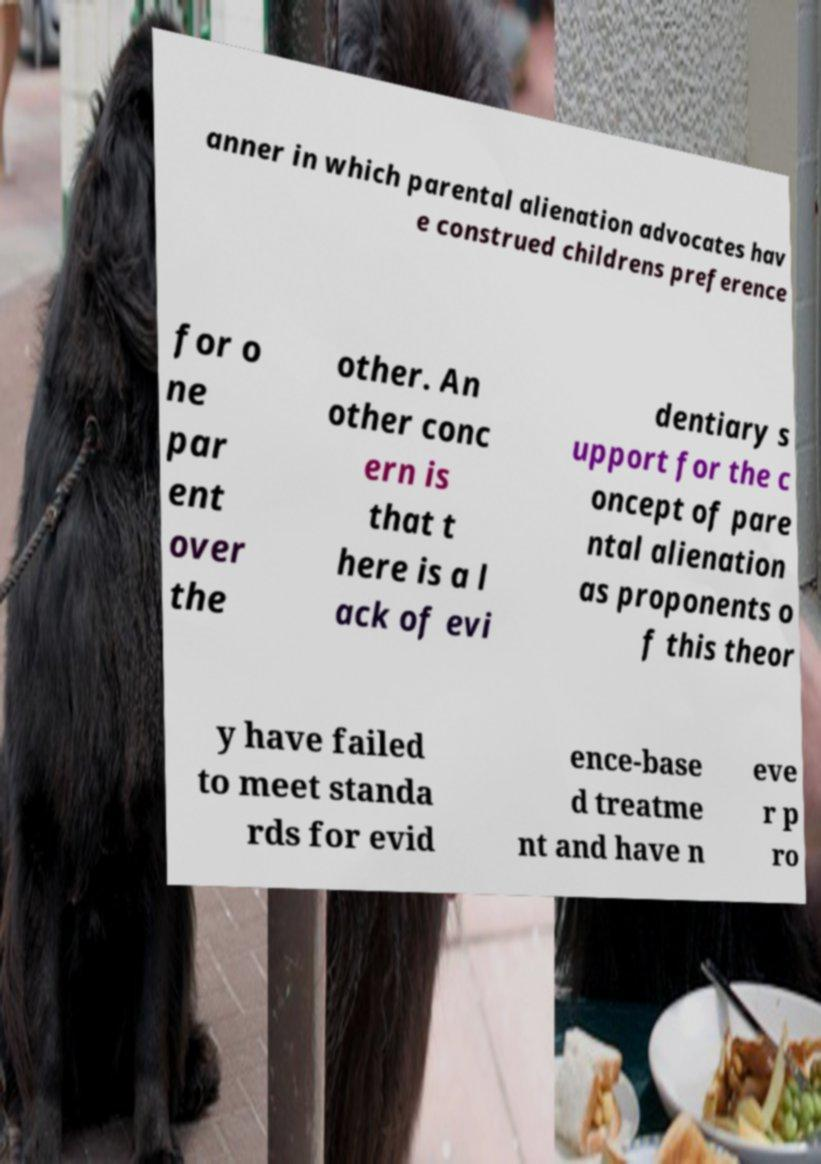There's text embedded in this image that I need extracted. Can you transcribe it verbatim? anner in which parental alienation advocates hav e construed childrens preference for o ne par ent over the other. An other conc ern is that t here is a l ack of evi dentiary s upport for the c oncept of pare ntal alienation as proponents o f this theor y have failed to meet standa rds for evid ence-base d treatme nt and have n eve r p ro 